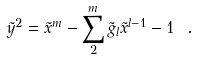<formula> <loc_0><loc_0><loc_500><loc_500>\tilde { y } ^ { 2 } = \tilde { x } ^ { m } - \sum _ { 2 } ^ { m } \tilde { g } _ { l } \tilde { x } ^ { l - 1 } - 1 \ .</formula> 